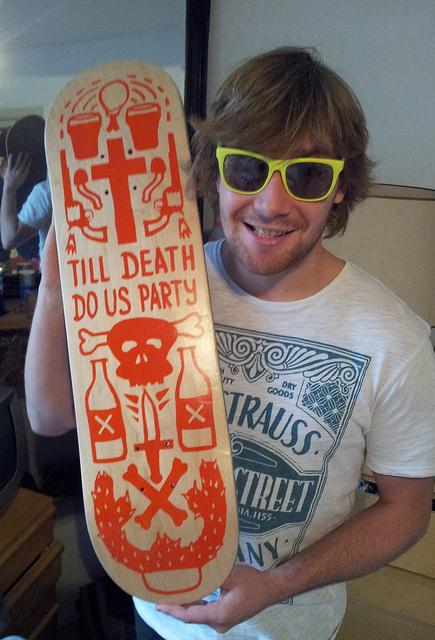What does the sign say?
Write a very short answer. Till death do us party. What is the man holding?
Answer briefly. Skateboard. What color are the sunglasses?
Be succinct. Yellow. Where is the man's right hand?
Give a very brief answer. Skateboard. Is the t-shirt a Levi Strauss?
Be succinct. Yes. Does the man have hair on his head?
Quick response, please. Yes. 